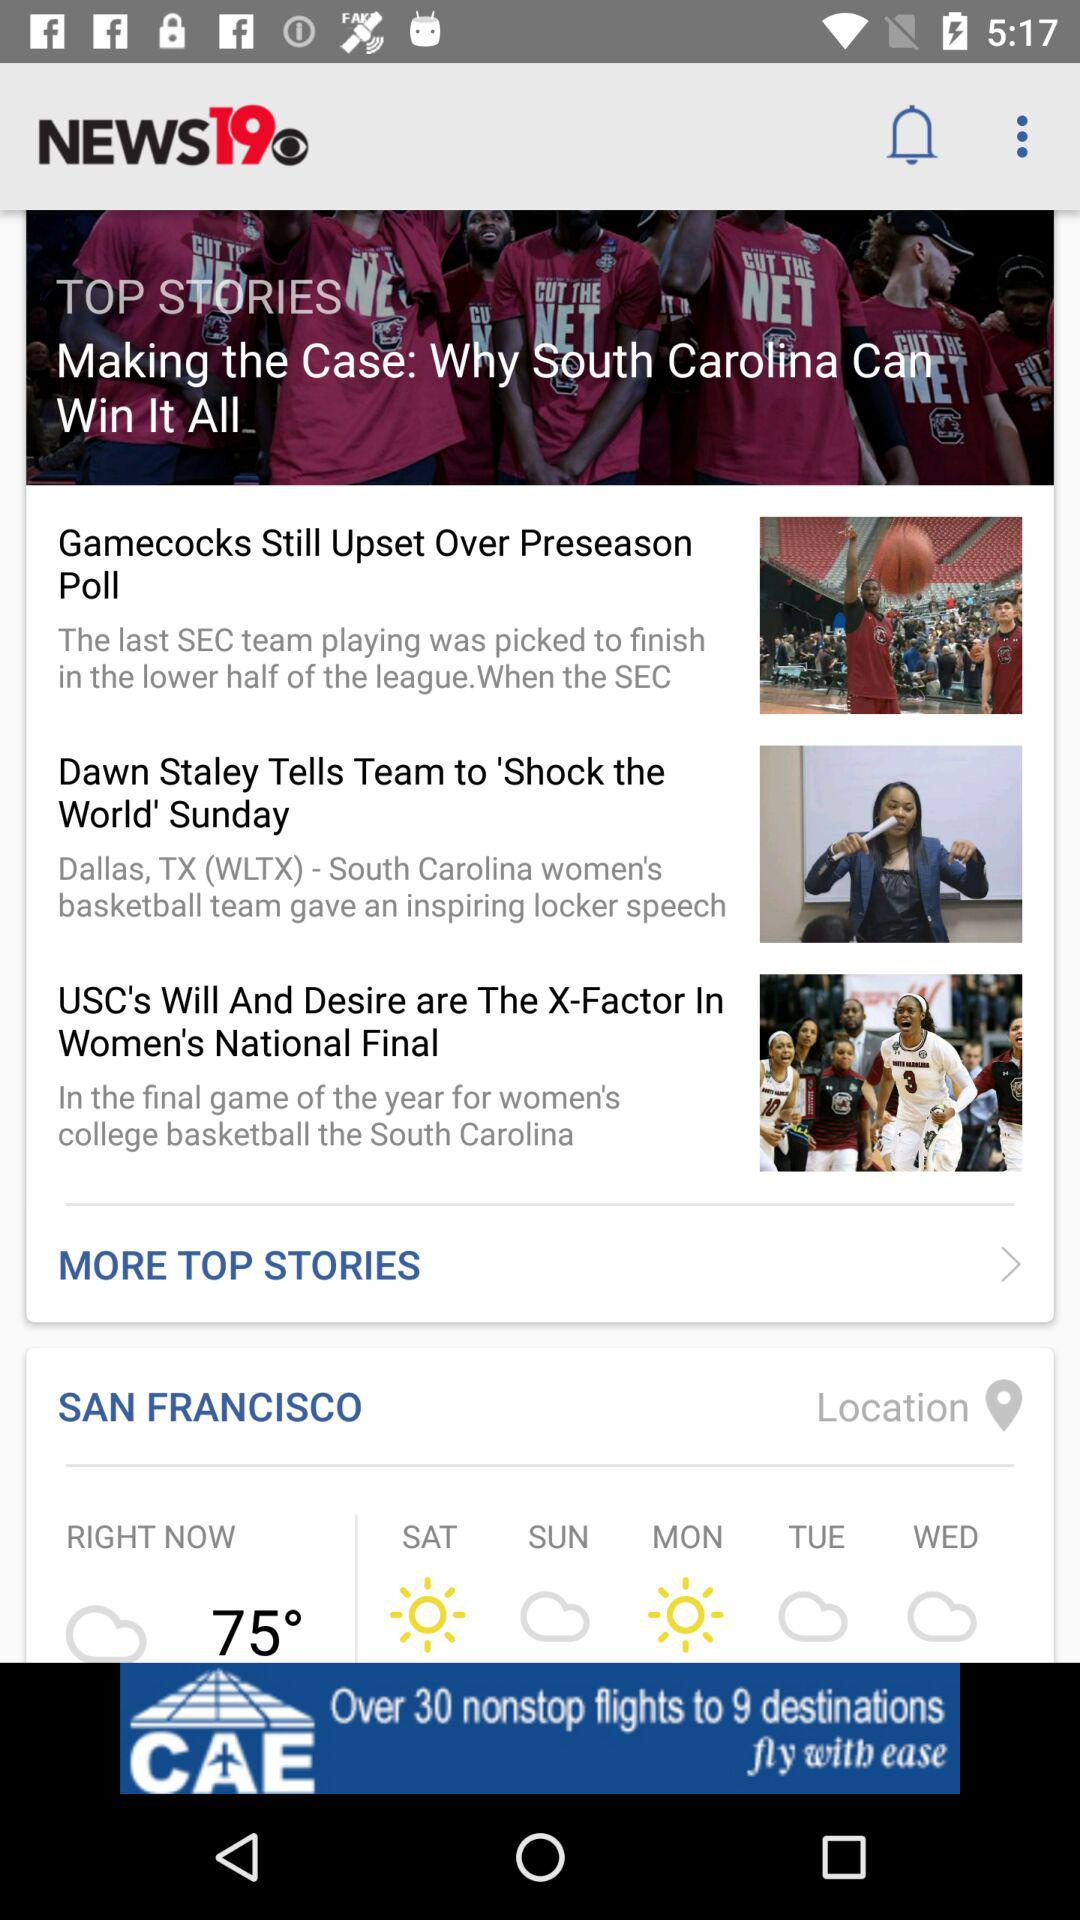What is the location? The location is San Francisco. 